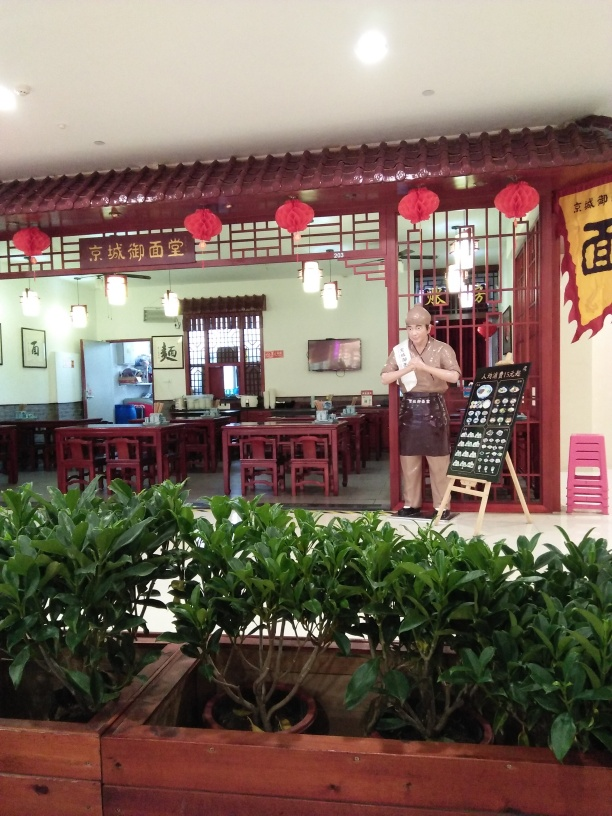Does it look like the shop has good customer service? While it's not possible to assess service quality from an image alone, the presence of what appears to be a staff member attentively holding a menu at the entrance suggests that they are ready to greet and serve customers, which is often indicative of good customer service. 